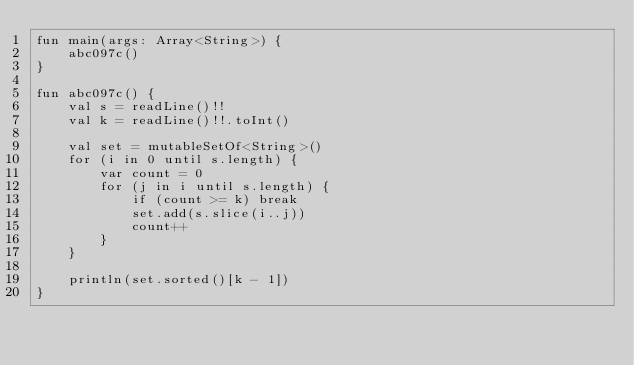Convert code to text. <code><loc_0><loc_0><loc_500><loc_500><_Kotlin_>fun main(args: Array<String>) {
    abc097c()
}

fun abc097c() {
    val s = readLine()!!
    val k = readLine()!!.toInt()

    val set = mutableSetOf<String>()
    for (i in 0 until s.length) {
        var count = 0
        for (j in i until s.length) {
            if (count >= k) break
            set.add(s.slice(i..j))
            count++
        }
    }

    println(set.sorted()[k - 1])
}
</code> 